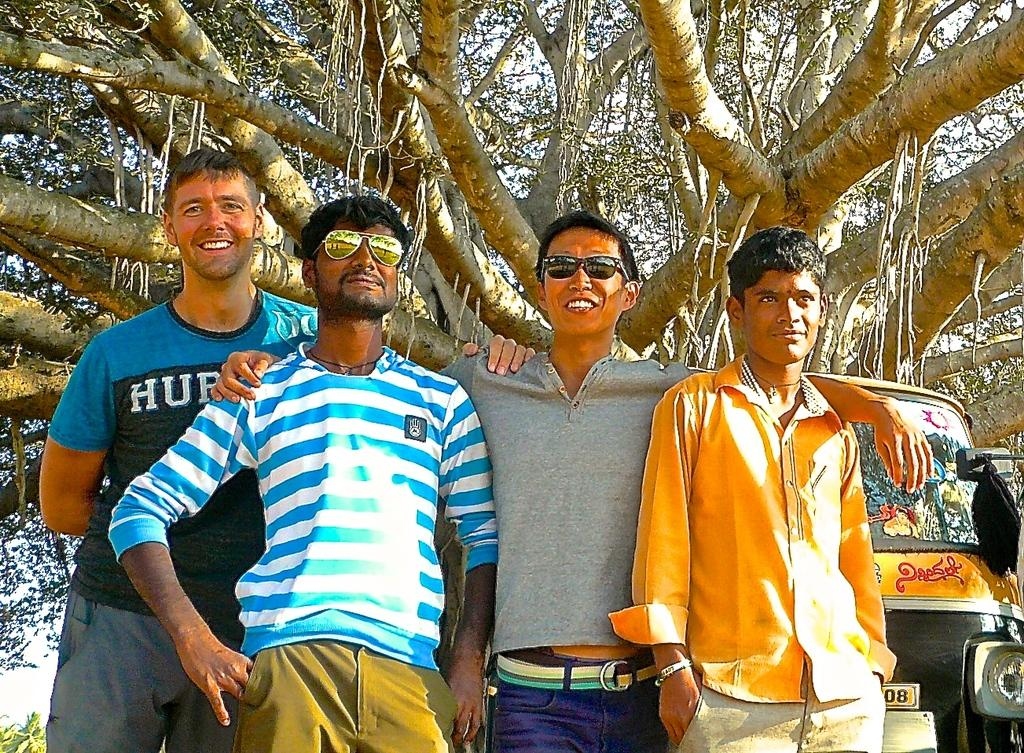How many people are present in the image? There are multiple persons in the image. What can be observed about some of the persons in the image? Some of the persons are wearing spectacles. What can be seen in the background of the image? There is a tree and an auto-rickshaw in the background of the image. What type of cherry is being used as a prop in the image? There is no cherry present in the image. What joke is being told by the persons in the image? There is no indication of a joke being told in the image. 